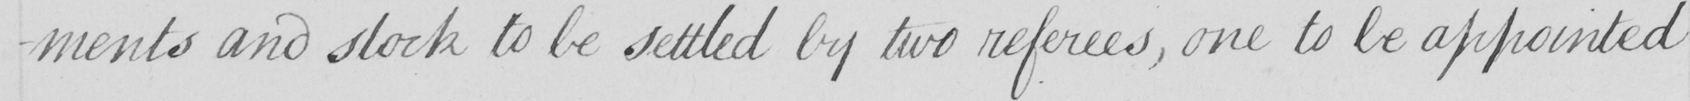What text is written in this handwritten line? -ments and stock to be settled by two referees , one to be appointed 